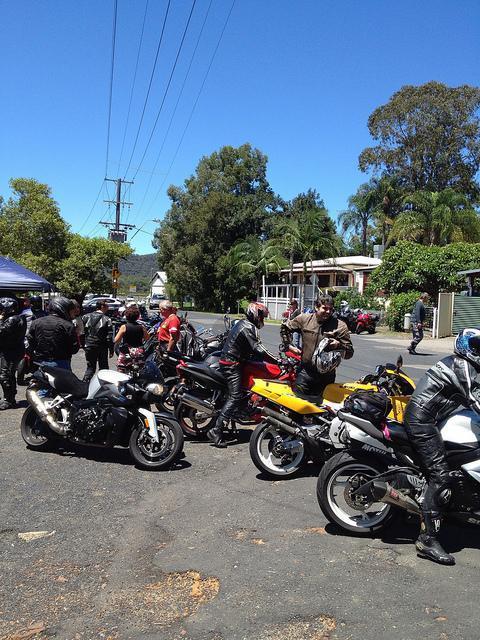What type weather is typical here?
From the following set of four choices, select the accurate answer to respond to the question.
Options: Tundra, freezing, all, tropical. Tropical. 